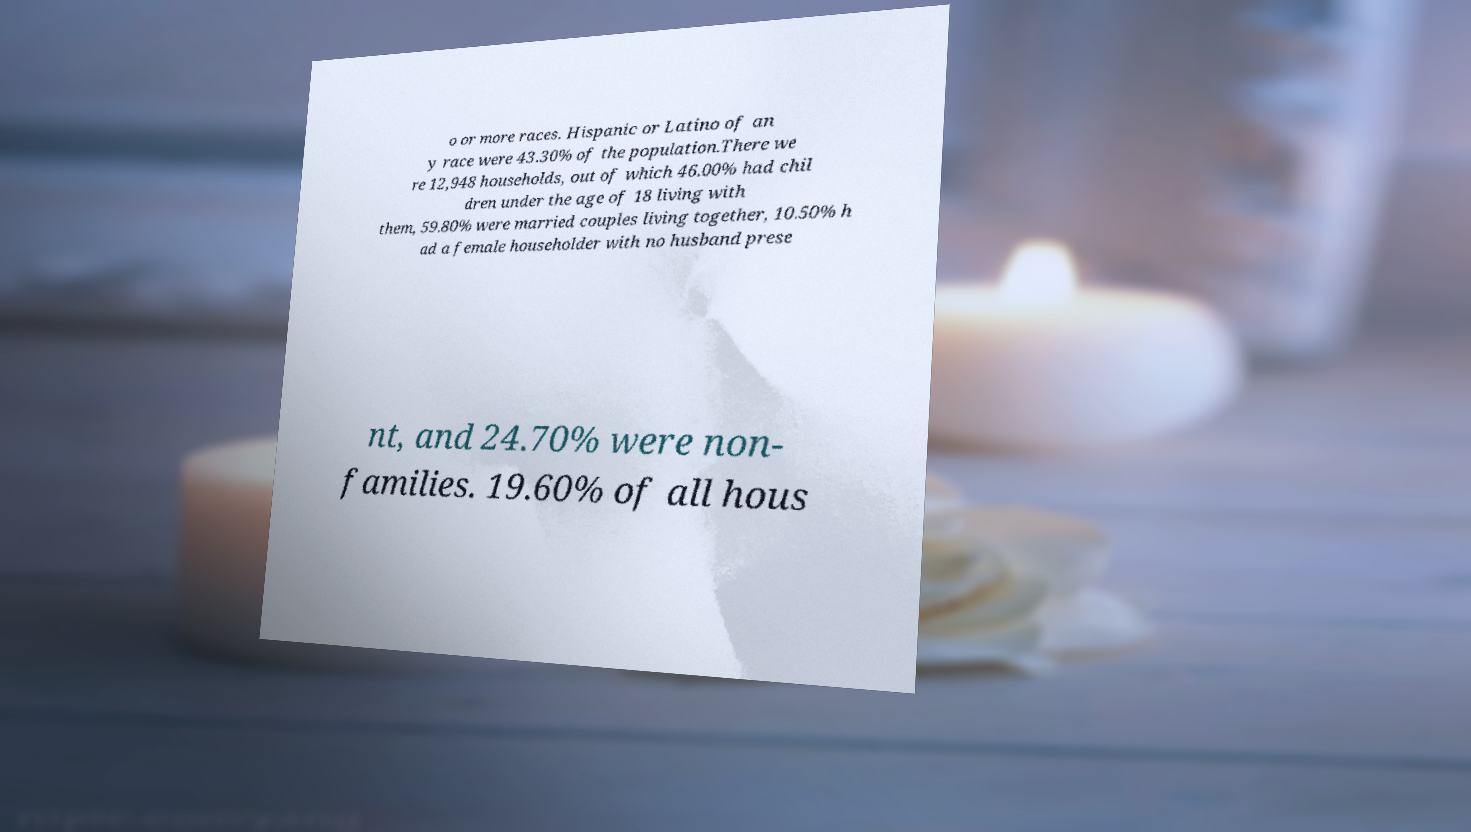Please identify and transcribe the text found in this image. o or more races. Hispanic or Latino of an y race were 43.30% of the population.There we re 12,948 households, out of which 46.00% had chil dren under the age of 18 living with them, 59.80% were married couples living together, 10.50% h ad a female householder with no husband prese nt, and 24.70% were non- families. 19.60% of all hous 